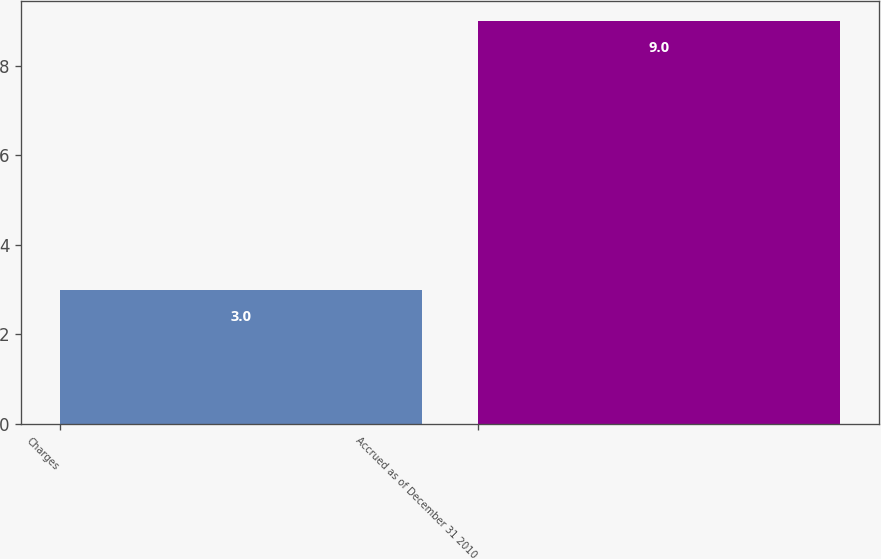Convert chart. <chart><loc_0><loc_0><loc_500><loc_500><bar_chart><fcel>Charges<fcel>Accrued as of December 31 2010<nl><fcel>3<fcel>9<nl></chart> 